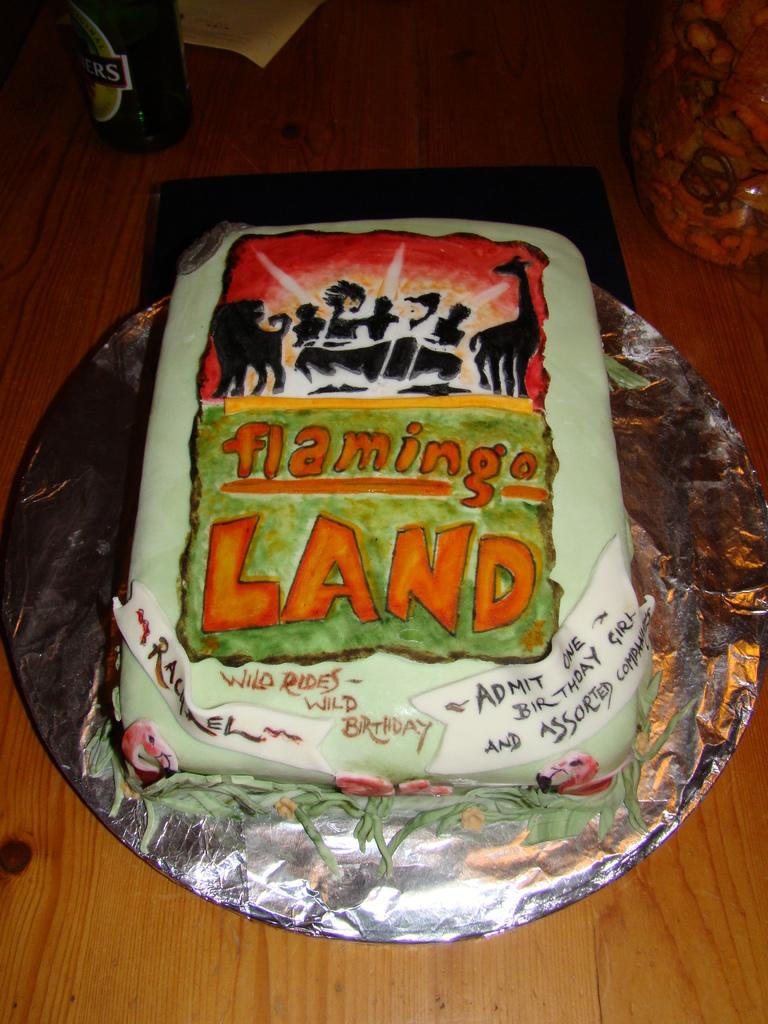What is the main subject of the image? There is a cake in the image. What is written or drawn on the cake? The cake has text on it. How is the cake protected or wrapped? The cake is placed in a foil. What other objects can be seen in the background of the image? There is a bottle, a paper, and a container in the background of the image. How many legs does the cake have in the image? Cakes do not have legs; they are inanimate objects. 